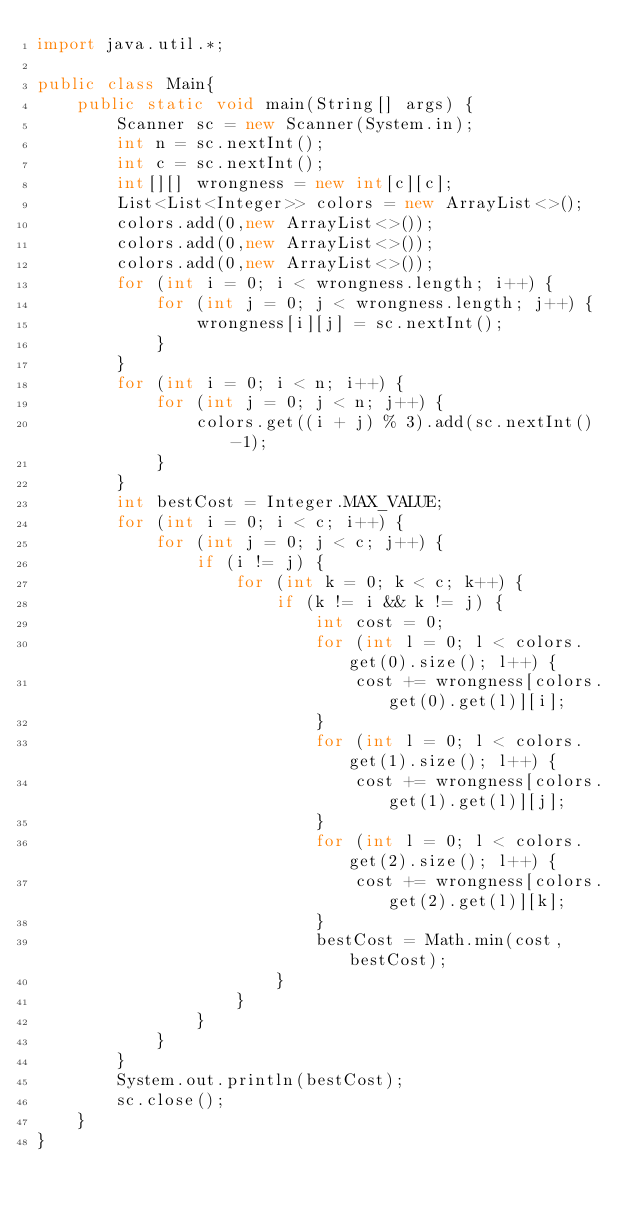<code> <loc_0><loc_0><loc_500><loc_500><_Java_>import java.util.*;

public class Main{
    public static void main(String[] args) {
        Scanner sc = new Scanner(System.in);
        int n = sc.nextInt();
        int c = sc.nextInt();
        int[][] wrongness = new int[c][c];
        List<List<Integer>> colors = new ArrayList<>();
        colors.add(0,new ArrayList<>());
        colors.add(0,new ArrayList<>());
        colors.add(0,new ArrayList<>());
        for (int i = 0; i < wrongness.length; i++) {
            for (int j = 0; j < wrongness.length; j++) {
                wrongness[i][j] = sc.nextInt();
            }
        }
        for (int i = 0; i < n; i++) {
            for (int j = 0; j < n; j++) {
                colors.get((i + j) % 3).add(sc.nextInt()-1);
            }
        }
        int bestCost = Integer.MAX_VALUE;
        for (int i = 0; i < c; i++) {
            for (int j = 0; j < c; j++) {
                if (i != j) {
                    for (int k = 0; k < c; k++) {
                        if (k != i && k != j) {
                            int cost = 0;
                            for (int l = 0; l < colors.get(0).size(); l++) {
                                cost += wrongness[colors.get(0).get(l)][i];
                            }
                            for (int l = 0; l < colors.get(1).size(); l++) {
                                cost += wrongness[colors.get(1).get(l)][j];
                            }
                            for (int l = 0; l < colors.get(2).size(); l++) {
                                cost += wrongness[colors.get(2).get(l)][k];
                            }
                            bestCost = Math.min(cost, bestCost);
                        }
                    }
                }
            }
        }
        System.out.println(bestCost);
        sc.close();
    }
}
</code> 